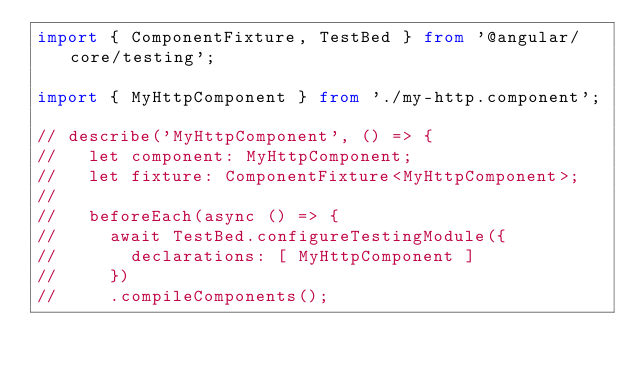<code> <loc_0><loc_0><loc_500><loc_500><_TypeScript_>import { ComponentFixture, TestBed } from '@angular/core/testing';

import { MyHttpComponent } from './my-http.component';

// describe('MyHttpComponent', () => {
//   let component: MyHttpComponent;
//   let fixture: ComponentFixture<MyHttpComponent>;
//
//   beforeEach(async () => {
//     await TestBed.configureTestingModule({
//       declarations: [ MyHttpComponent ]
//     })
//     .compileComponents();</code> 